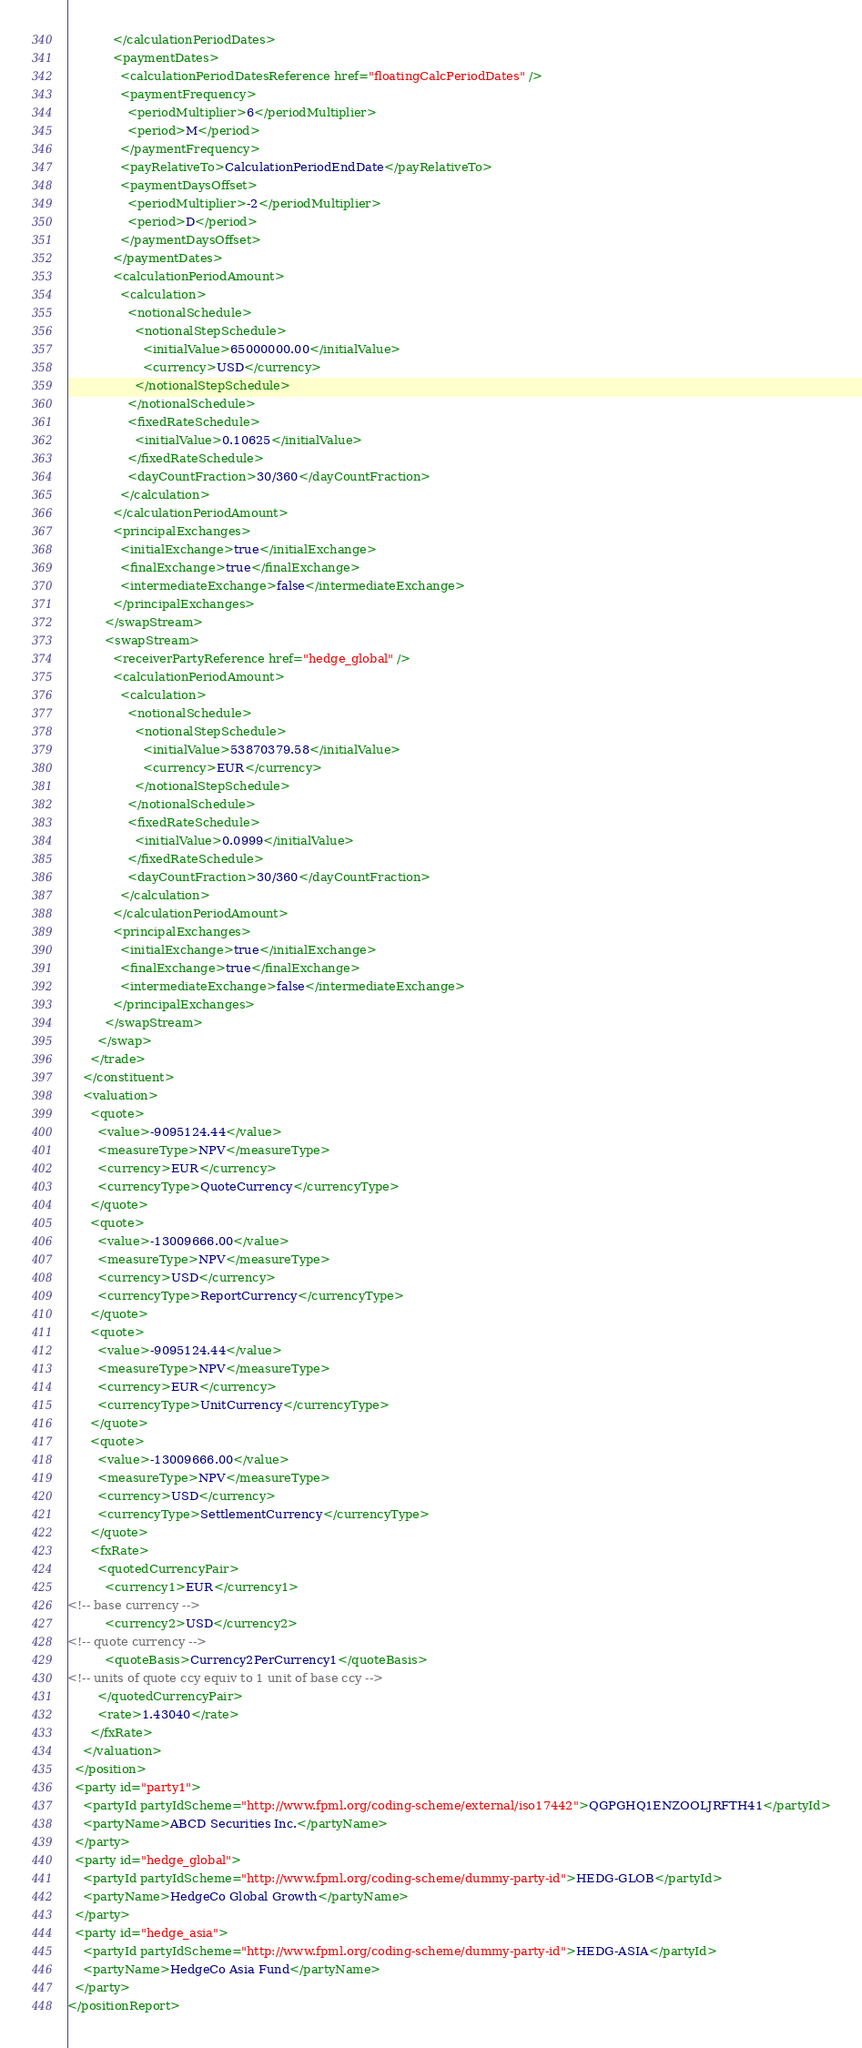Convert code to text. <code><loc_0><loc_0><loc_500><loc_500><_XML_>            </calculationPeriodDates>
            <paymentDates>
              <calculationPeriodDatesReference href="floatingCalcPeriodDates" />
              <paymentFrequency>
                <periodMultiplier>6</periodMultiplier>
                <period>M</period>
              </paymentFrequency>
              <payRelativeTo>CalculationPeriodEndDate</payRelativeTo>
              <paymentDaysOffset>
                <periodMultiplier>-2</periodMultiplier>
                <period>D</period>
              </paymentDaysOffset>
            </paymentDates>
            <calculationPeriodAmount>
              <calculation>
                <notionalSchedule>
                  <notionalStepSchedule>
                    <initialValue>65000000.00</initialValue>
                    <currency>USD</currency>
                  </notionalStepSchedule>
                </notionalSchedule>
                <fixedRateSchedule>
                  <initialValue>0.10625</initialValue>
                </fixedRateSchedule>
                <dayCountFraction>30/360</dayCountFraction>
              </calculation>
            </calculationPeriodAmount>
            <principalExchanges>
              <initialExchange>true</initialExchange>
              <finalExchange>true</finalExchange>
              <intermediateExchange>false</intermediateExchange>
            </principalExchanges>
          </swapStream>
          <swapStream>
            <receiverPartyReference href="hedge_global" />
            <calculationPeriodAmount>
              <calculation>
                <notionalSchedule>
                  <notionalStepSchedule>
                    <initialValue>53870379.58</initialValue>
                    <currency>EUR</currency>
                  </notionalStepSchedule>
                </notionalSchedule>
                <fixedRateSchedule>
                  <initialValue>0.0999</initialValue>
                </fixedRateSchedule>
                <dayCountFraction>30/360</dayCountFraction>
              </calculation>
            </calculationPeriodAmount>
            <principalExchanges>
              <initialExchange>true</initialExchange>
              <finalExchange>true</finalExchange>
              <intermediateExchange>false</intermediateExchange>
            </principalExchanges>
          </swapStream>
        </swap>
      </trade>
    </constituent>
    <valuation>
      <quote>
        <value>-9095124.44</value>
        <measureType>NPV</measureType>
        <currency>EUR</currency>
        <currencyType>QuoteCurrency</currencyType>
      </quote>
      <quote>
        <value>-13009666.00</value>
        <measureType>NPV</measureType>
        <currency>USD</currency>
        <currencyType>ReportCurrency</currencyType>
      </quote>
      <quote>
        <value>-9095124.44</value>
        <measureType>NPV</measureType>
        <currency>EUR</currency>
        <currencyType>UnitCurrency</currencyType>
      </quote>
      <quote>
        <value>-13009666.00</value>
        <measureType>NPV</measureType>
        <currency>USD</currency>
        <currencyType>SettlementCurrency</currencyType>
      </quote>
      <fxRate>
        <quotedCurrencyPair>
          <currency1>EUR</currency1>
<!-- base currency -->
          <currency2>USD</currency2>
<!-- quote currency -->
          <quoteBasis>Currency2PerCurrency1</quoteBasis>
<!-- units of quote ccy equiv to 1 unit of base ccy -->
        </quotedCurrencyPair>
        <rate>1.43040</rate>
      </fxRate>
    </valuation>
  </position>
  <party id="party1">
    <partyId partyIdScheme="http://www.fpml.org/coding-scheme/external/iso17442">QGPGHQ1ENZOOLJRFTH41</partyId>
    <partyName>ABCD Securities Inc.</partyName>
  </party>
  <party id="hedge_global">
    <partyId partyIdScheme="http://www.fpml.org/coding-scheme/dummy-party-id">HEDG-GLOB</partyId>
    <partyName>HedgeCo Global Growth</partyName>
  </party>
  <party id="hedge_asia">
    <partyId partyIdScheme="http://www.fpml.org/coding-scheme/dummy-party-id">HEDG-ASIA</partyId>
    <partyName>HedgeCo Asia Fund</partyName>
  </party>
</positionReport>

</code> 